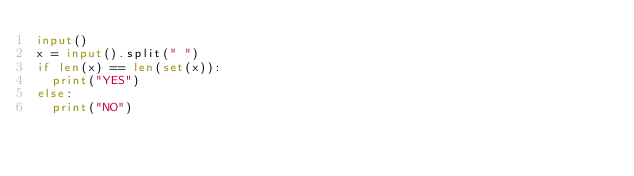Convert code to text. <code><loc_0><loc_0><loc_500><loc_500><_Python_>input()
x = input().split(" ")
if len(x) == len(set(x)):
  print("YES")
else:
  print("NO")</code> 